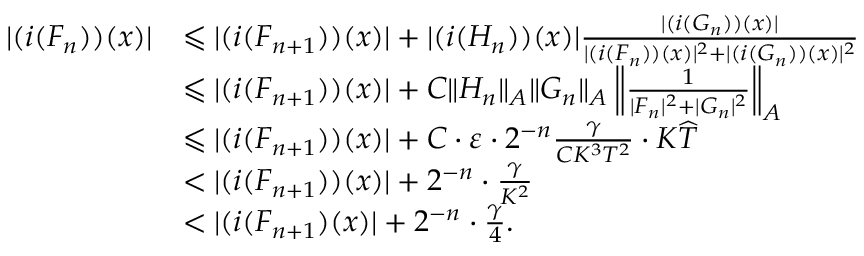Convert formula to latex. <formula><loc_0><loc_0><loc_500><loc_500>\begin{array} { r l } { | ( i ( F _ { n } ) ) ( x ) | } & { \leqslant | ( i ( F _ { n + 1 } ) ) ( x ) | + | ( i ( H _ { n } ) ) ( x ) | \frac { | ( i ( G _ { n } ) ) ( x ) | } { | ( i ( F _ { n } ) ) ( x ) | ^ { 2 } + | ( i ( G _ { n } ) ) ( x ) | ^ { 2 } } } \\ & { \leqslant | ( i ( F _ { n + 1 } ) ) ( x ) | + C \| H _ { n } \| _ { A } \| G _ { n } \| _ { A } \left \| \frac { 1 } { | F _ { n } | ^ { 2 } + | G _ { n } | ^ { 2 } } \right \| _ { A } } \\ & { \leqslant | ( i ( F _ { n + 1 } ) ) ( x ) | + C \cdot \varepsilon \cdot 2 ^ { - n } \frac { \gamma } { C K ^ { 3 } T ^ { 2 } } \cdot K \widehat { T } } \\ & { < | ( i ( F _ { n + 1 } ) ) ( x ) | + 2 ^ { - n } \cdot \frac { \gamma } { K ^ { 2 } } } \\ & { < | ( i ( F _ { n + 1 } ) ( x ) | + 2 ^ { - n } \cdot \frac { \gamma } { 4 } . } \end{array}</formula> 